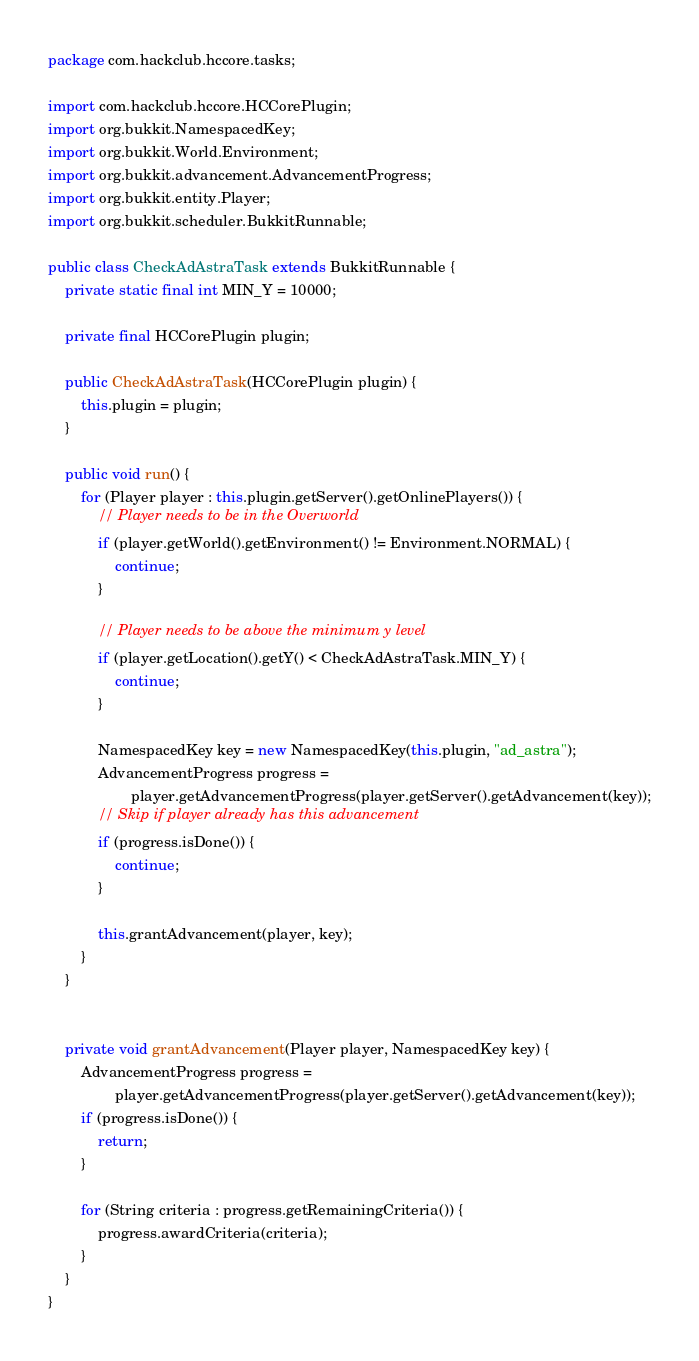<code> <loc_0><loc_0><loc_500><loc_500><_Java_>package com.hackclub.hccore.tasks;

import com.hackclub.hccore.HCCorePlugin;
import org.bukkit.NamespacedKey;
import org.bukkit.World.Environment;
import org.bukkit.advancement.AdvancementProgress;
import org.bukkit.entity.Player;
import org.bukkit.scheduler.BukkitRunnable;

public class CheckAdAstraTask extends BukkitRunnable {
    private static final int MIN_Y = 10000;

    private final HCCorePlugin plugin;

    public CheckAdAstraTask(HCCorePlugin plugin) {
        this.plugin = plugin;
    }

    public void run() {
        for (Player player : this.plugin.getServer().getOnlinePlayers()) {
            // Player needs to be in the Overworld
            if (player.getWorld().getEnvironment() != Environment.NORMAL) {
                continue;
            }

            // Player needs to be above the minimum y level
            if (player.getLocation().getY() < CheckAdAstraTask.MIN_Y) {
                continue;
            }

            NamespacedKey key = new NamespacedKey(this.plugin, "ad_astra");
            AdvancementProgress progress =
                    player.getAdvancementProgress(player.getServer().getAdvancement(key));
            // Skip if player already has this advancement
            if (progress.isDone()) {
                continue;
            }

            this.grantAdvancement(player, key);
        }
    }


    private void grantAdvancement(Player player, NamespacedKey key) {
        AdvancementProgress progress =
                player.getAdvancementProgress(player.getServer().getAdvancement(key));
        if (progress.isDone()) {
            return;
        }

        for (String criteria : progress.getRemainingCriteria()) {
            progress.awardCriteria(criteria);
        }
    }
}
</code> 